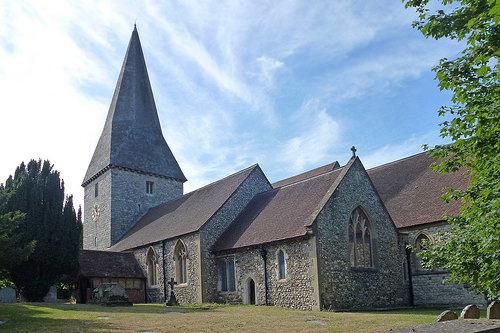<image>
Can you confirm if the sky is above the house? Yes. The sky is positioned above the house in the vertical space, higher up in the scene. 